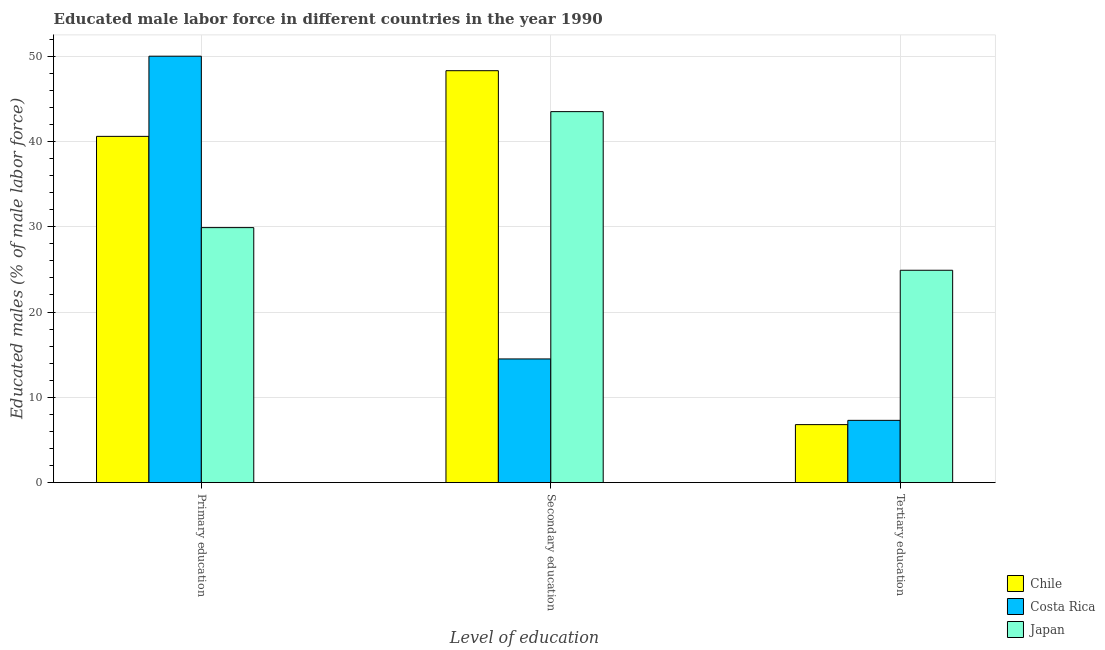How many different coloured bars are there?
Your answer should be very brief. 3. How many groups of bars are there?
Provide a short and direct response. 3. Are the number of bars on each tick of the X-axis equal?
Provide a short and direct response. Yes. How many bars are there on the 2nd tick from the left?
Make the answer very short. 3. How many bars are there on the 1st tick from the right?
Your answer should be compact. 3. What is the label of the 3rd group of bars from the left?
Your answer should be compact. Tertiary education. What is the percentage of male labor force who received tertiary education in Costa Rica?
Provide a short and direct response. 7.3. Across all countries, what is the maximum percentage of male labor force who received secondary education?
Your response must be concise. 48.3. Across all countries, what is the minimum percentage of male labor force who received secondary education?
Make the answer very short. 14.5. In which country was the percentage of male labor force who received tertiary education maximum?
Give a very brief answer. Japan. In which country was the percentage of male labor force who received primary education minimum?
Make the answer very short. Japan. What is the total percentage of male labor force who received secondary education in the graph?
Ensure brevity in your answer.  106.3. What is the difference between the percentage of male labor force who received secondary education in Japan and that in Costa Rica?
Give a very brief answer. 29. What is the difference between the percentage of male labor force who received secondary education in Chile and the percentage of male labor force who received tertiary education in Japan?
Provide a short and direct response. 23.4. What is the average percentage of male labor force who received primary education per country?
Make the answer very short. 40.17. What is the ratio of the percentage of male labor force who received secondary education in Costa Rica to that in Japan?
Keep it short and to the point. 0.33. What is the difference between the highest and the second highest percentage of male labor force who received tertiary education?
Ensure brevity in your answer.  17.6. What is the difference between the highest and the lowest percentage of male labor force who received primary education?
Keep it short and to the point. 20.1. In how many countries, is the percentage of male labor force who received tertiary education greater than the average percentage of male labor force who received tertiary education taken over all countries?
Provide a succinct answer. 1. Is it the case that in every country, the sum of the percentage of male labor force who received primary education and percentage of male labor force who received secondary education is greater than the percentage of male labor force who received tertiary education?
Provide a short and direct response. Yes. Are the values on the major ticks of Y-axis written in scientific E-notation?
Your answer should be very brief. No. Where does the legend appear in the graph?
Your answer should be very brief. Bottom right. How are the legend labels stacked?
Offer a very short reply. Vertical. What is the title of the graph?
Provide a succinct answer. Educated male labor force in different countries in the year 1990. Does "Benin" appear as one of the legend labels in the graph?
Keep it short and to the point. No. What is the label or title of the X-axis?
Your response must be concise. Level of education. What is the label or title of the Y-axis?
Ensure brevity in your answer.  Educated males (% of male labor force). What is the Educated males (% of male labor force) of Chile in Primary education?
Offer a very short reply. 40.6. What is the Educated males (% of male labor force) in Japan in Primary education?
Provide a succinct answer. 29.9. What is the Educated males (% of male labor force) of Chile in Secondary education?
Give a very brief answer. 48.3. What is the Educated males (% of male labor force) of Japan in Secondary education?
Make the answer very short. 43.5. What is the Educated males (% of male labor force) of Chile in Tertiary education?
Your answer should be very brief. 6.8. What is the Educated males (% of male labor force) in Costa Rica in Tertiary education?
Your response must be concise. 7.3. What is the Educated males (% of male labor force) of Japan in Tertiary education?
Keep it short and to the point. 24.9. Across all Level of education, what is the maximum Educated males (% of male labor force) of Chile?
Your answer should be very brief. 48.3. Across all Level of education, what is the maximum Educated males (% of male labor force) of Costa Rica?
Give a very brief answer. 50. Across all Level of education, what is the maximum Educated males (% of male labor force) in Japan?
Offer a very short reply. 43.5. Across all Level of education, what is the minimum Educated males (% of male labor force) in Chile?
Keep it short and to the point. 6.8. Across all Level of education, what is the minimum Educated males (% of male labor force) in Costa Rica?
Offer a very short reply. 7.3. Across all Level of education, what is the minimum Educated males (% of male labor force) of Japan?
Provide a succinct answer. 24.9. What is the total Educated males (% of male labor force) in Chile in the graph?
Keep it short and to the point. 95.7. What is the total Educated males (% of male labor force) of Costa Rica in the graph?
Provide a succinct answer. 71.8. What is the total Educated males (% of male labor force) of Japan in the graph?
Offer a terse response. 98.3. What is the difference between the Educated males (% of male labor force) in Chile in Primary education and that in Secondary education?
Make the answer very short. -7.7. What is the difference between the Educated males (% of male labor force) of Costa Rica in Primary education and that in Secondary education?
Make the answer very short. 35.5. What is the difference between the Educated males (% of male labor force) of Japan in Primary education and that in Secondary education?
Provide a succinct answer. -13.6. What is the difference between the Educated males (% of male labor force) of Chile in Primary education and that in Tertiary education?
Make the answer very short. 33.8. What is the difference between the Educated males (% of male labor force) of Costa Rica in Primary education and that in Tertiary education?
Provide a short and direct response. 42.7. What is the difference between the Educated males (% of male labor force) in Chile in Secondary education and that in Tertiary education?
Make the answer very short. 41.5. What is the difference between the Educated males (% of male labor force) of Chile in Primary education and the Educated males (% of male labor force) of Costa Rica in Secondary education?
Your answer should be compact. 26.1. What is the difference between the Educated males (% of male labor force) of Chile in Primary education and the Educated males (% of male labor force) of Japan in Secondary education?
Offer a very short reply. -2.9. What is the difference between the Educated males (% of male labor force) in Chile in Primary education and the Educated males (% of male labor force) in Costa Rica in Tertiary education?
Provide a succinct answer. 33.3. What is the difference between the Educated males (% of male labor force) in Chile in Primary education and the Educated males (% of male labor force) in Japan in Tertiary education?
Give a very brief answer. 15.7. What is the difference between the Educated males (% of male labor force) of Costa Rica in Primary education and the Educated males (% of male labor force) of Japan in Tertiary education?
Provide a short and direct response. 25.1. What is the difference between the Educated males (% of male labor force) in Chile in Secondary education and the Educated males (% of male labor force) in Costa Rica in Tertiary education?
Offer a very short reply. 41. What is the difference between the Educated males (% of male labor force) of Chile in Secondary education and the Educated males (% of male labor force) of Japan in Tertiary education?
Offer a very short reply. 23.4. What is the average Educated males (% of male labor force) in Chile per Level of education?
Your response must be concise. 31.9. What is the average Educated males (% of male labor force) of Costa Rica per Level of education?
Your answer should be compact. 23.93. What is the average Educated males (% of male labor force) of Japan per Level of education?
Make the answer very short. 32.77. What is the difference between the Educated males (% of male labor force) of Chile and Educated males (% of male labor force) of Japan in Primary education?
Your response must be concise. 10.7. What is the difference between the Educated males (% of male labor force) in Costa Rica and Educated males (% of male labor force) in Japan in Primary education?
Make the answer very short. 20.1. What is the difference between the Educated males (% of male labor force) in Chile and Educated males (% of male labor force) in Costa Rica in Secondary education?
Your answer should be compact. 33.8. What is the difference between the Educated males (% of male labor force) in Chile and Educated males (% of male labor force) in Japan in Tertiary education?
Ensure brevity in your answer.  -18.1. What is the difference between the Educated males (% of male labor force) of Costa Rica and Educated males (% of male labor force) of Japan in Tertiary education?
Your answer should be compact. -17.6. What is the ratio of the Educated males (% of male labor force) of Chile in Primary education to that in Secondary education?
Your answer should be very brief. 0.84. What is the ratio of the Educated males (% of male labor force) of Costa Rica in Primary education to that in Secondary education?
Keep it short and to the point. 3.45. What is the ratio of the Educated males (% of male labor force) of Japan in Primary education to that in Secondary education?
Offer a very short reply. 0.69. What is the ratio of the Educated males (% of male labor force) of Chile in Primary education to that in Tertiary education?
Give a very brief answer. 5.97. What is the ratio of the Educated males (% of male labor force) in Costa Rica in Primary education to that in Tertiary education?
Ensure brevity in your answer.  6.85. What is the ratio of the Educated males (% of male labor force) in Japan in Primary education to that in Tertiary education?
Your answer should be very brief. 1.2. What is the ratio of the Educated males (% of male labor force) in Chile in Secondary education to that in Tertiary education?
Offer a terse response. 7.1. What is the ratio of the Educated males (% of male labor force) in Costa Rica in Secondary education to that in Tertiary education?
Keep it short and to the point. 1.99. What is the ratio of the Educated males (% of male labor force) in Japan in Secondary education to that in Tertiary education?
Give a very brief answer. 1.75. What is the difference between the highest and the second highest Educated males (% of male labor force) in Chile?
Offer a very short reply. 7.7. What is the difference between the highest and the second highest Educated males (% of male labor force) of Costa Rica?
Provide a succinct answer. 35.5. What is the difference between the highest and the lowest Educated males (% of male labor force) in Chile?
Keep it short and to the point. 41.5. What is the difference between the highest and the lowest Educated males (% of male labor force) of Costa Rica?
Give a very brief answer. 42.7. 